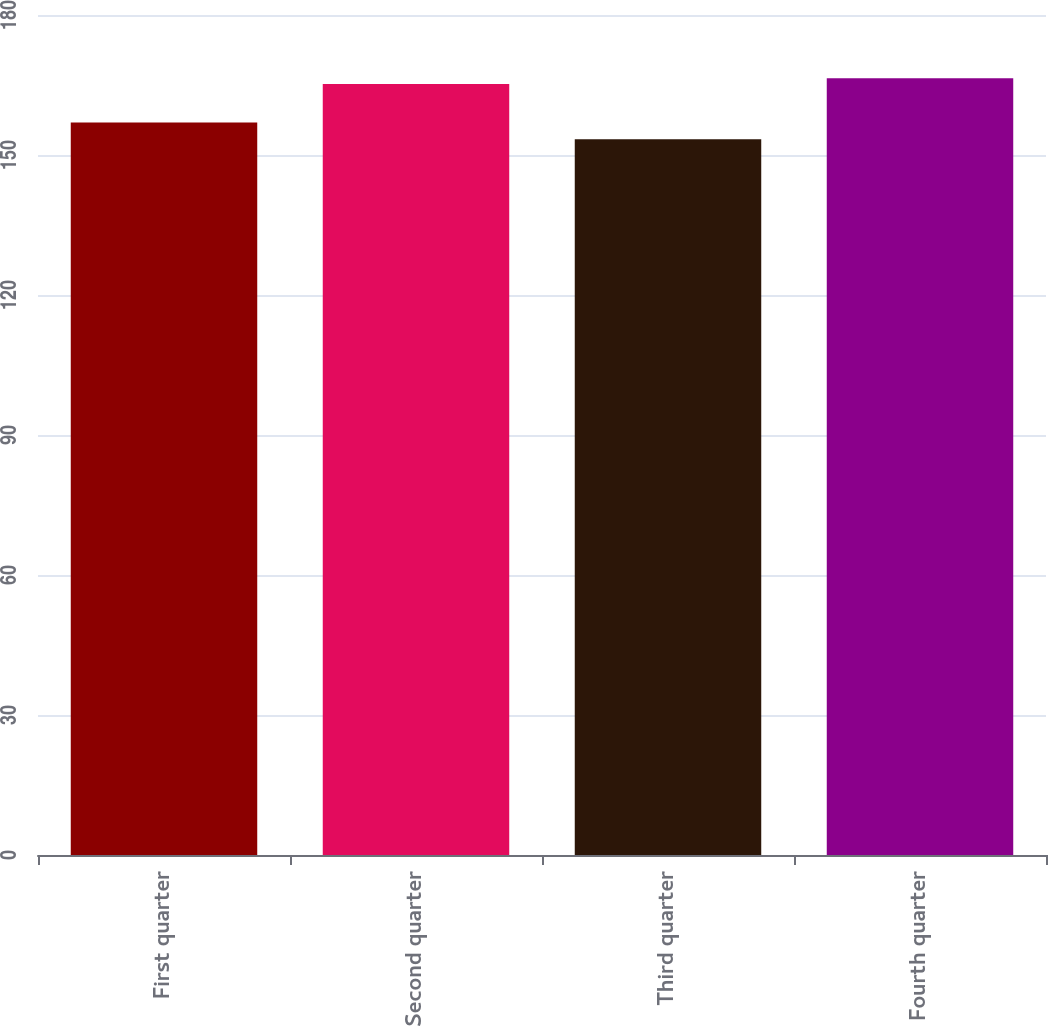<chart> <loc_0><loc_0><loc_500><loc_500><bar_chart><fcel>First quarter<fcel>Second quarter<fcel>Third quarter<fcel>Fourth quarter<nl><fcel>156.96<fcel>165.23<fcel>153.38<fcel>166.42<nl></chart> 